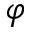<formula> <loc_0><loc_0><loc_500><loc_500>\varphi</formula> 